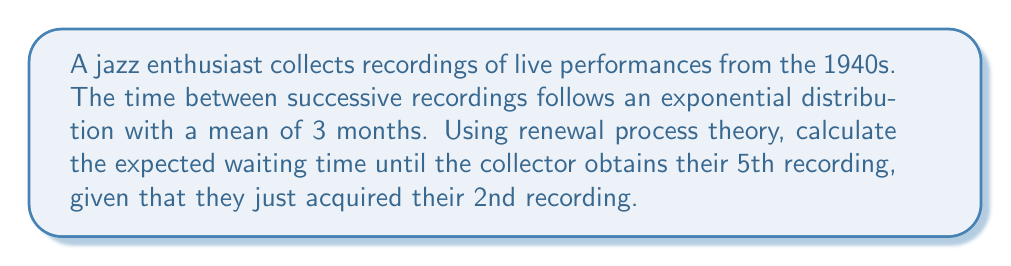Provide a solution to this math problem. Let's approach this step-by-step using renewal process theory:

1) In a renewal process with exponentially distributed inter-arrival times, the process is memoryless. This means that regardless of when the last event occurred, the expected time until the next event is always the same.

2) The mean time between recordings is 3 months. In exponential distribution, this is equal to $\frac{1}{\lambda}$, where $\lambda$ is the rate parameter. So, $\frac{1}{\lambda} = 3$, or $\lambda = \frac{1}{3}$.

3) The collector has just acquired their 2nd recording and wants to know the expected time until the 5th recording. This means we need to calculate the expected time for 3 more recordings to occur.

4) In a renewal process, the expected time for n events to occur is n times the expected time for one event. Therefore:

   $E[T_3] = 3 \cdot E[T_1] = 3 \cdot 3 = 9$

5) Thus, the expected waiting time from the 2nd recording to the 5th recording is 9 months.

6) We can also express this using the renewal function $m(t)$:

   $m(t) = \lambda t = \frac{1}{3} t$

   The expected number of renewals in time t is $m(t) = 3$, so:

   $3 = \frac{1}{3} t$
   $t = 9$

This confirms our result of 9 months.
Answer: 9 months 